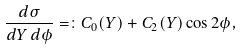Convert formula to latex. <formula><loc_0><loc_0><loc_500><loc_500>\frac { d \sigma } { d Y \, d \phi } = \colon C _ { 0 } ( Y ) + C _ { 2 } ( Y ) \cos 2 \phi ,</formula> 